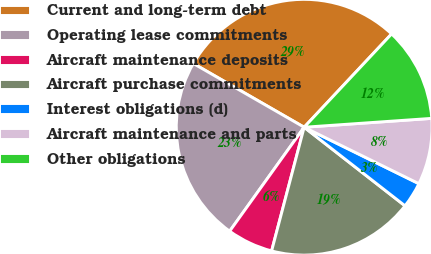Convert chart to OTSL. <chart><loc_0><loc_0><loc_500><loc_500><pie_chart><fcel>Current and long-term debt<fcel>Operating lease commitments<fcel>Aircraft maintenance deposits<fcel>Aircraft purchase commitments<fcel>Interest obligations (d)<fcel>Aircraft maintenance and parts<fcel>Other obligations<nl><fcel>28.68%<fcel>23.41%<fcel>5.8%<fcel>18.56%<fcel>3.26%<fcel>8.38%<fcel>11.91%<nl></chart> 